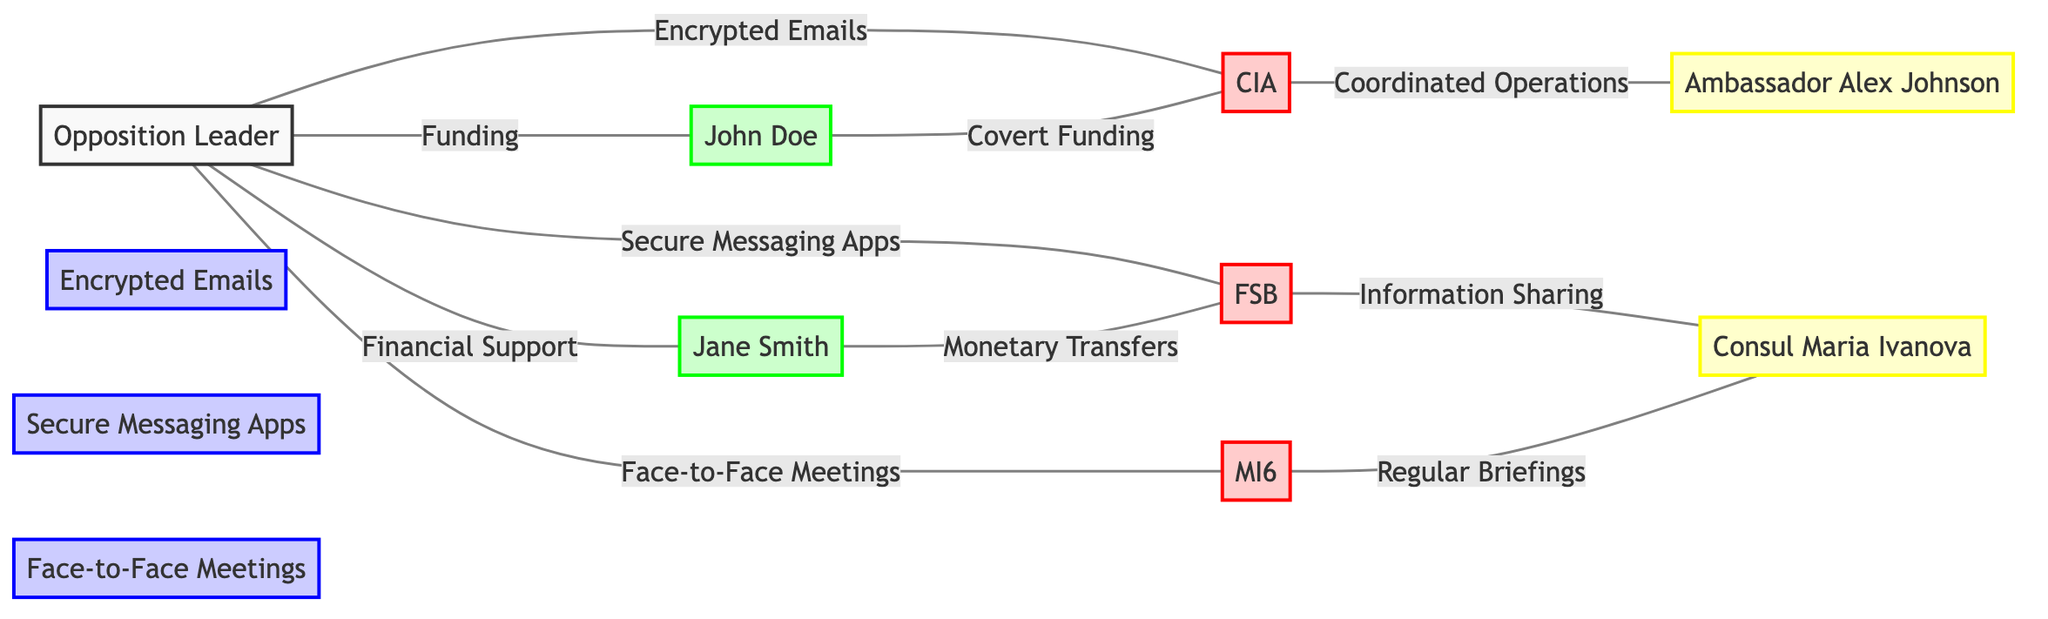What is the total number of nodes in the diagram? The diagram lists the following nodes: Opposition Leader, CIA, FSB, MI6, John Doe, Jane Smith, Encrypted Emails, Secure Messaging Apps, Face-to-Face Meetings, Ambassador Alex Johnson, and Consul Maria Ivanova. Counting these gives a total of 11 nodes.
Answer: 11 Which communication channel connects the Opposition Leader to the CIA? The diagram indicates that the Opposition Leader and the CIA are connected by the communication channel labeled "Encrypted Emails." This is the specific label shown on the edge connecting these two nodes.
Answer: Encrypted Emails How many foreign intelligence agencies are linked to the Opposition Leader? The diagram shows three distinct foreign intelligence agencies connected to the Opposition Leader: CIA, FSB, and MI6. To answer, we simply count these agencies appearing in edges from the Opposition Leader.
Answer: 3 Who provides covert funding to the CIA? According to the diagram, the individual providing covert funding to the CIA is John Doe. This is indicated by the edge leading from John Doe to CIA labeled "Covert Funding."
Answer: John Doe What is the relationship between MI6 and Consul Maria Ivanova? The diagram specifies that MI6 has a relationship with Consul Maria Ivanova through regular briefings as defined on the edge connecting them. The label on this edge clearly states this relationship.
Answer: Regular Briefings Which financial benefactor supports the FSB? The diagram indicates that Jane Smith supports the FSB through monetary transfers, denoted as the relationship between her and the FSB in the edge labeled "Monetary Transfers."
Answer: Jane Smith What type of connection exists between the CIA and Ambassador Alex Johnson? The connection between the CIA and Ambassador Alex Johnson is one of coordinated operations, as described on the edge linking these two nodes, clearly labeled accordingly.
Answer: Coordinated Operations Name one communication channel through which the Opposition Leader communicates with the FSB. The diagram clearly indicates that the Opposition Leader communicates with the FSB through "Secure Messaging Apps," which is the label on their connecting edge.
Answer: Secure Messaging Apps How many edges are connected to Financial Benefactor A? The diagram shows two edges connected to Financial Benefactor A: one to CIA labeled "Covert Funding" and another to the Opposition Leader labeled "Funding." Counting these edges gives a total of 2.
Answer: 2 